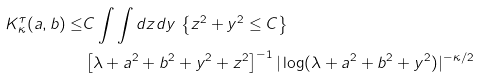<formula> <loc_0><loc_0><loc_500><loc_500>K _ { \kappa } ^ { \tau } ( a , b ) \leq & C \int \int d z d y \, \left \{ { z ^ { 2 } } + y ^ { 2 } \leq C \right \} \\ & \left [ \lambda + a ^ { 2 } + b ^ { 2 } + y ^ { 2 } + z ^ { 2 } \right ] ^ { - 1 } | \log ( \lambda + a ^ { 2 } + b ^ { 2 } + y ^ { 2 } ) | ^ { - \kappa / 2 }</formula> 